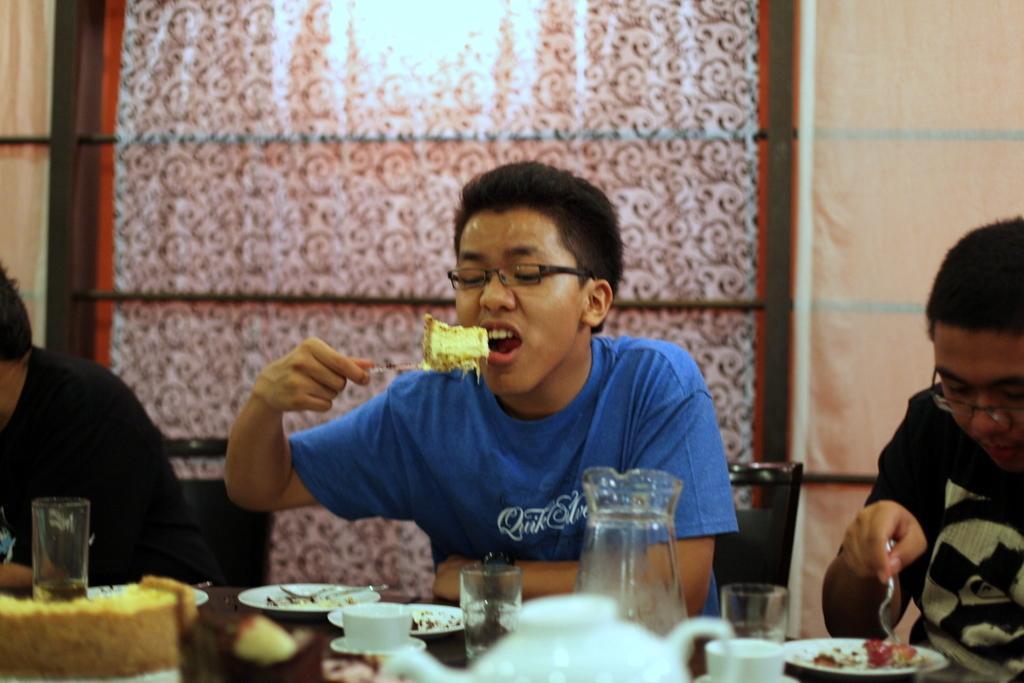How would you summarize this image in a sentence or two? In this image there is a boy siting in the chair and eating the cake with the spoon. In front of him there is a table on which there are plates,cups,jars,glasses,kettle and a cake on it. In the background there is a curtain. On the right side there is a person who is sitting in the chair by keeping the spoon on the plate. 